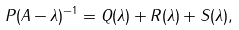Convert formula to latex. <formula><loc_0><loc_0><loc_500><loc_500>P ( A - \lambda ) ^ { - 1 } = Q ( \lambda ) + R ( \lambda ) + S ( \lambda ) ,</formula> 